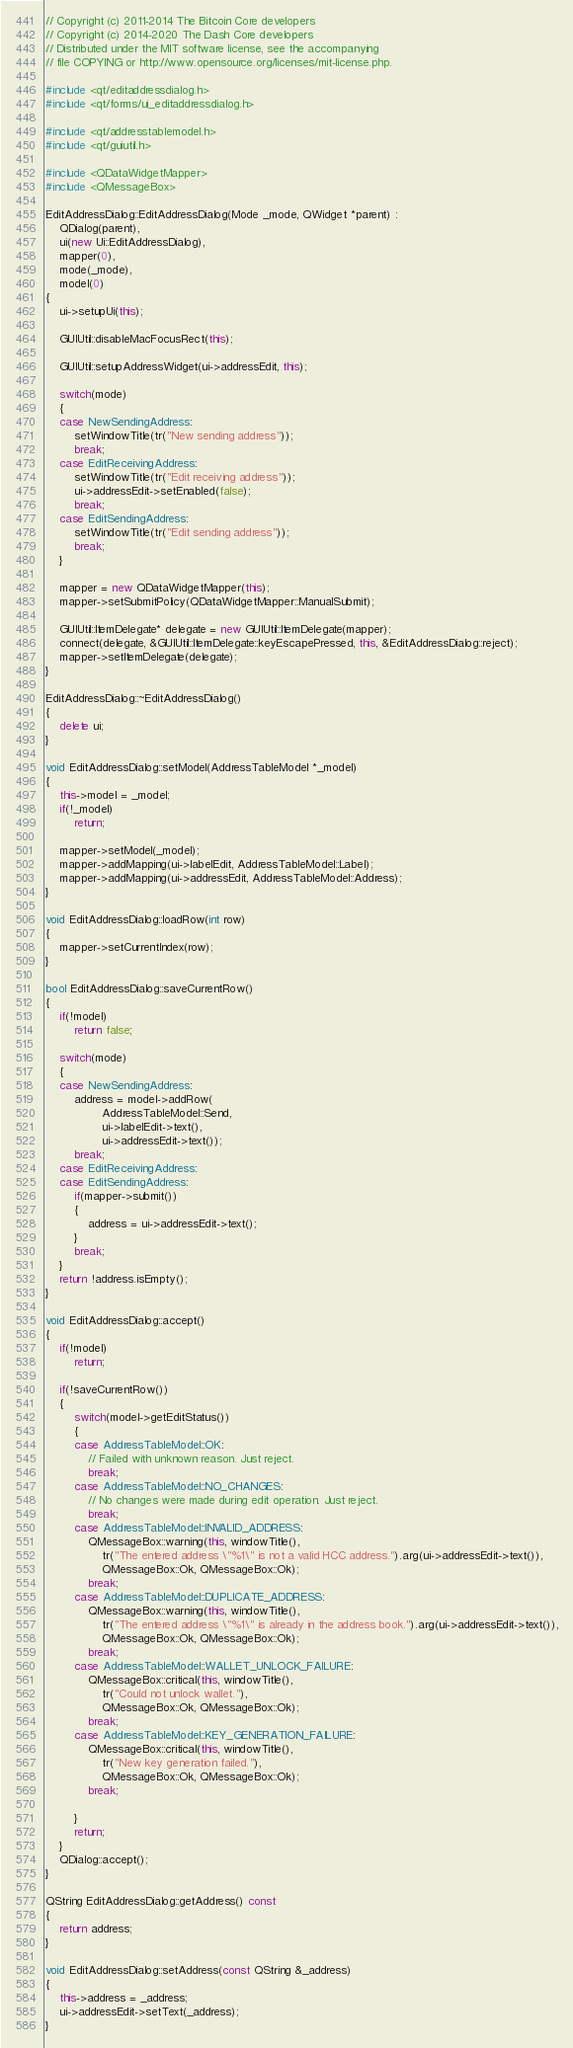Convert code to text. <code><loc_0><loc_0><loc_500><loc_500><_C++_>// Copyright (c) 2011-2014 The Bitcoin Core developers
// Copyright (c) 2014-2020 The Dash Core developers
// Distributed under the MIT software license, see the accompanying
// file COPYING or http://www.opensource.org/licenses/mit-license.php.

#include <qt/editaddressdialog.h>
#include <qt/forms/ui_editaddressdialog.h>

#include <qt/addresstablemodel.h>
#include <qt/guiutil.h>

#include <QDataWidgetMapper>
#include <QMessageBox>

EditAddressDialog::EditAddressDialog(Mode _mode, QWidget *parent) :
    QDialog(parent),
    ui(new Ui::EditAddressDialog),
    mapper(0),
    mode(_mode),
    model(0)
{
    ui->setupUi(this);

    GUIUtil::disableMacFocusRect(this);

    GUIUtil::setupAddressWidget(ui->addressEdit, this);

    switch(mode)
    {
    case NewSendingAddress:
        setWindowTitle(tr("New sending address"));
        break;
    case EditReceivingAddress:
        setWindowTitle(tr("Edit receiving address"));
        ui->addressEdit->setEnabled(false);
        break;
    case EditSendingAddress:
        setWindowTitle(tr("Edit sending address"));
        break;
    }

    mapper = new QDataWidgetMapper(this);
    mapper->setSubmitPolicy(QDataWidgetMapper::ManualSubmit);

    GUIUtil::ItemDelegate* delegate = new GUIUtil::ItemDelegate(mapper);
    connect(delegate, &GUIUtil::ItemDelegate::keyEscapePressed, this, &EditAddressDialog::reject);
    mapper->setItemDelegate(delegate);
}

EditAddressDialog::~EditAddressDialog()
{
    delete ui;
}

void EditAddressDialog::setModel(AddressTableModel *_model)
{
    this->model = _model;
    if(!_model)
        return;

    mapper->setModel(_model);
    mapper->addMapping(ui->labelEdit, AddressTableModel::Label);
    mapper->addMapping(ui->addressEdit, AddressTableModel::Address);
}

void EditAddressDialog::loadRow(int row)
{
    mapper->setCurrentIndex(row);
}

bool EditAddressDialog::saveCurrentRow()
{
    if(!model)
        return false;

    switch(mode)
    {
    case NewSendingAddress:
        address = model->addRow(
                AddressTableModel::Send,
                ui->labelEdit->text(),
                ui->addressEdit->text());
        break;
    case EditReceivingAddress:
    case EditSendingAddress:
        if(mapper->submit())
        {
            address = ui->addressEdit->text();
        }
        break;
    }
    return !address.isEmpty();
}

void EditAddressDialog::accept()
{
    if(!model)
        return;

    if(!saveCurrentRow())
    {
        switch(model->getEditStatus())
        {
        case AddressTableModel::OK:
            // Failed with unknown reason. Just reject.
            break;
        case AddressTableModel::NO_CHANGES:
            // No changes were made during edit operation. Just reject.
            break;
        case AddressTableModel::INVALID_ADDRESS:
            QMessageBox::warning(this, windowTitle(),
                tr("The entered address \"%1\" is not a valid HCC address.").arg(ui->addressEdit->text()),
                QMessageBox::Ok, QMessageBox::Ok);
            break;
        case AddressTableModel::DUPLICATE_ADDRESS:
            QMessageBox::warning(this, windowTitle(),
                tr("The entered address \"%1\" is already in the address book.").arg(ui->addressEdit->text()),
                QMessageBox::Ok, QMessageBox::Ok);
            break;
        case AddressTableModel::WALLET_UNLOCK_FAILURE:
            QMessageBox::critical(this, windowTitle(),
                tr("Could not unlock wallet."),
                QMessageBox::Ok, QMessageBox::Ok);
            break;
        case AddressTableModel::KEY_GENERATION_FAILURE:
            QMessageBox::critical(this, windowTitle(),
                tr("New key generation failed."),
                QMessageBox::Ok, QMessageBox::Ok);
            break;

        }
        return;
    }
    QDialog::accept();
}

QString EditAddressDialog::getAddress() const
{
    return address;
}

void EditAddressDialog::setAddress(const QString &_address)
{
    this->address = _address;
    ui->addressEdit->setText(_address);
}
</code> 